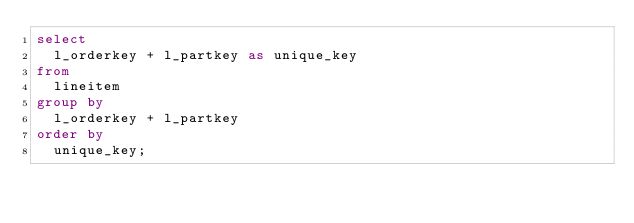<code> <loc_0><loc_0><loc_500><loc_500><_SQL_>select
  l_orderkey + l_partkey as unique_key
from
  lineitem
group by
  l_orderkey + l_partkey
order by
  unique_key;</code> 